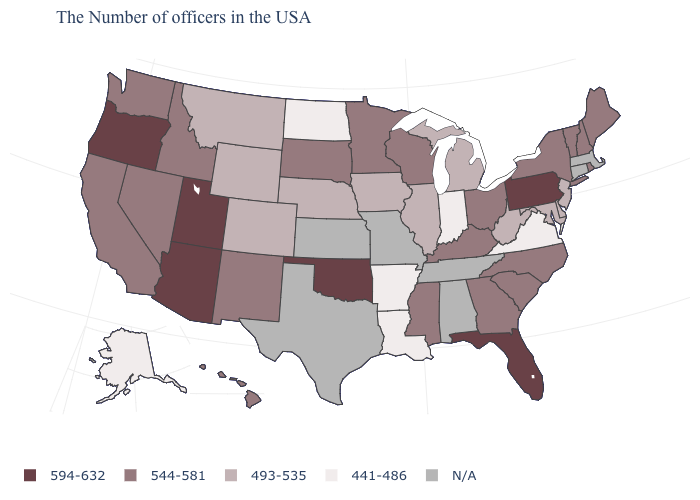What is the value of Tennessee?
Give a very brief answer. N/A. What is the highest value in the USA?
Concise answer only. 594-632. Among the states that border Virginia , which have the highest value?
Short answer required. North Carolina, Kentucky. What is the value of Virginia?
Concise answer only. 441-486. Which states have the lowest value in the Northeast?
Short answer required. New Jersey. What is the lowest value in states that border Indiana?
Quick response, please. 493-535. Which states have the lowest value in the USA?
Write a very short answer. Virginia, Indiana, Louisiana, Arkansas, North Dakota, Alaska. What is the value of West Virginia?
Keep it brief. 493-535. Does Pennsylvania have the highest value in the USA?
Answer briefly. Yes. Among the states that border Arizona , does Utah have the highest value?
Concise answer only. Yes. Name the states that have a value in the range 493-535?
Keep it brief. New Jersey, Delaware, Maryland, West Virginia, Michigan, Illinois, Iowa, Nebraska, Wyoming, Colorado, Montana. Name the states that have a value in the range 544-581?
Answer briefly. Maine, Rhode Island, New Hampshire, Vermont, New York, North Carolina, South Carolina, Ohio, Georgia, Kentucky, Wisconsin, Mississippi, Minnesota, South Dakota, New Mexico, Idaho, Nevada, California, Washington, Hawaii. Name the states that have a value in the range 544-581?
Write a very short answer. Maine, Rhode Island, New Hampshire, Vermont, New York, North Carolina, South Carolina, Ohio, Georgia, Kentucky, Wisconsin, Mississippi, Minnesota, South Dakota, New Mexico, Idaho, Nevada, California, Washington, Hawaii. Among the states that border Oregon , which have the lowest value?
Be succinct. Idaho, Nevada, California, Washington. 